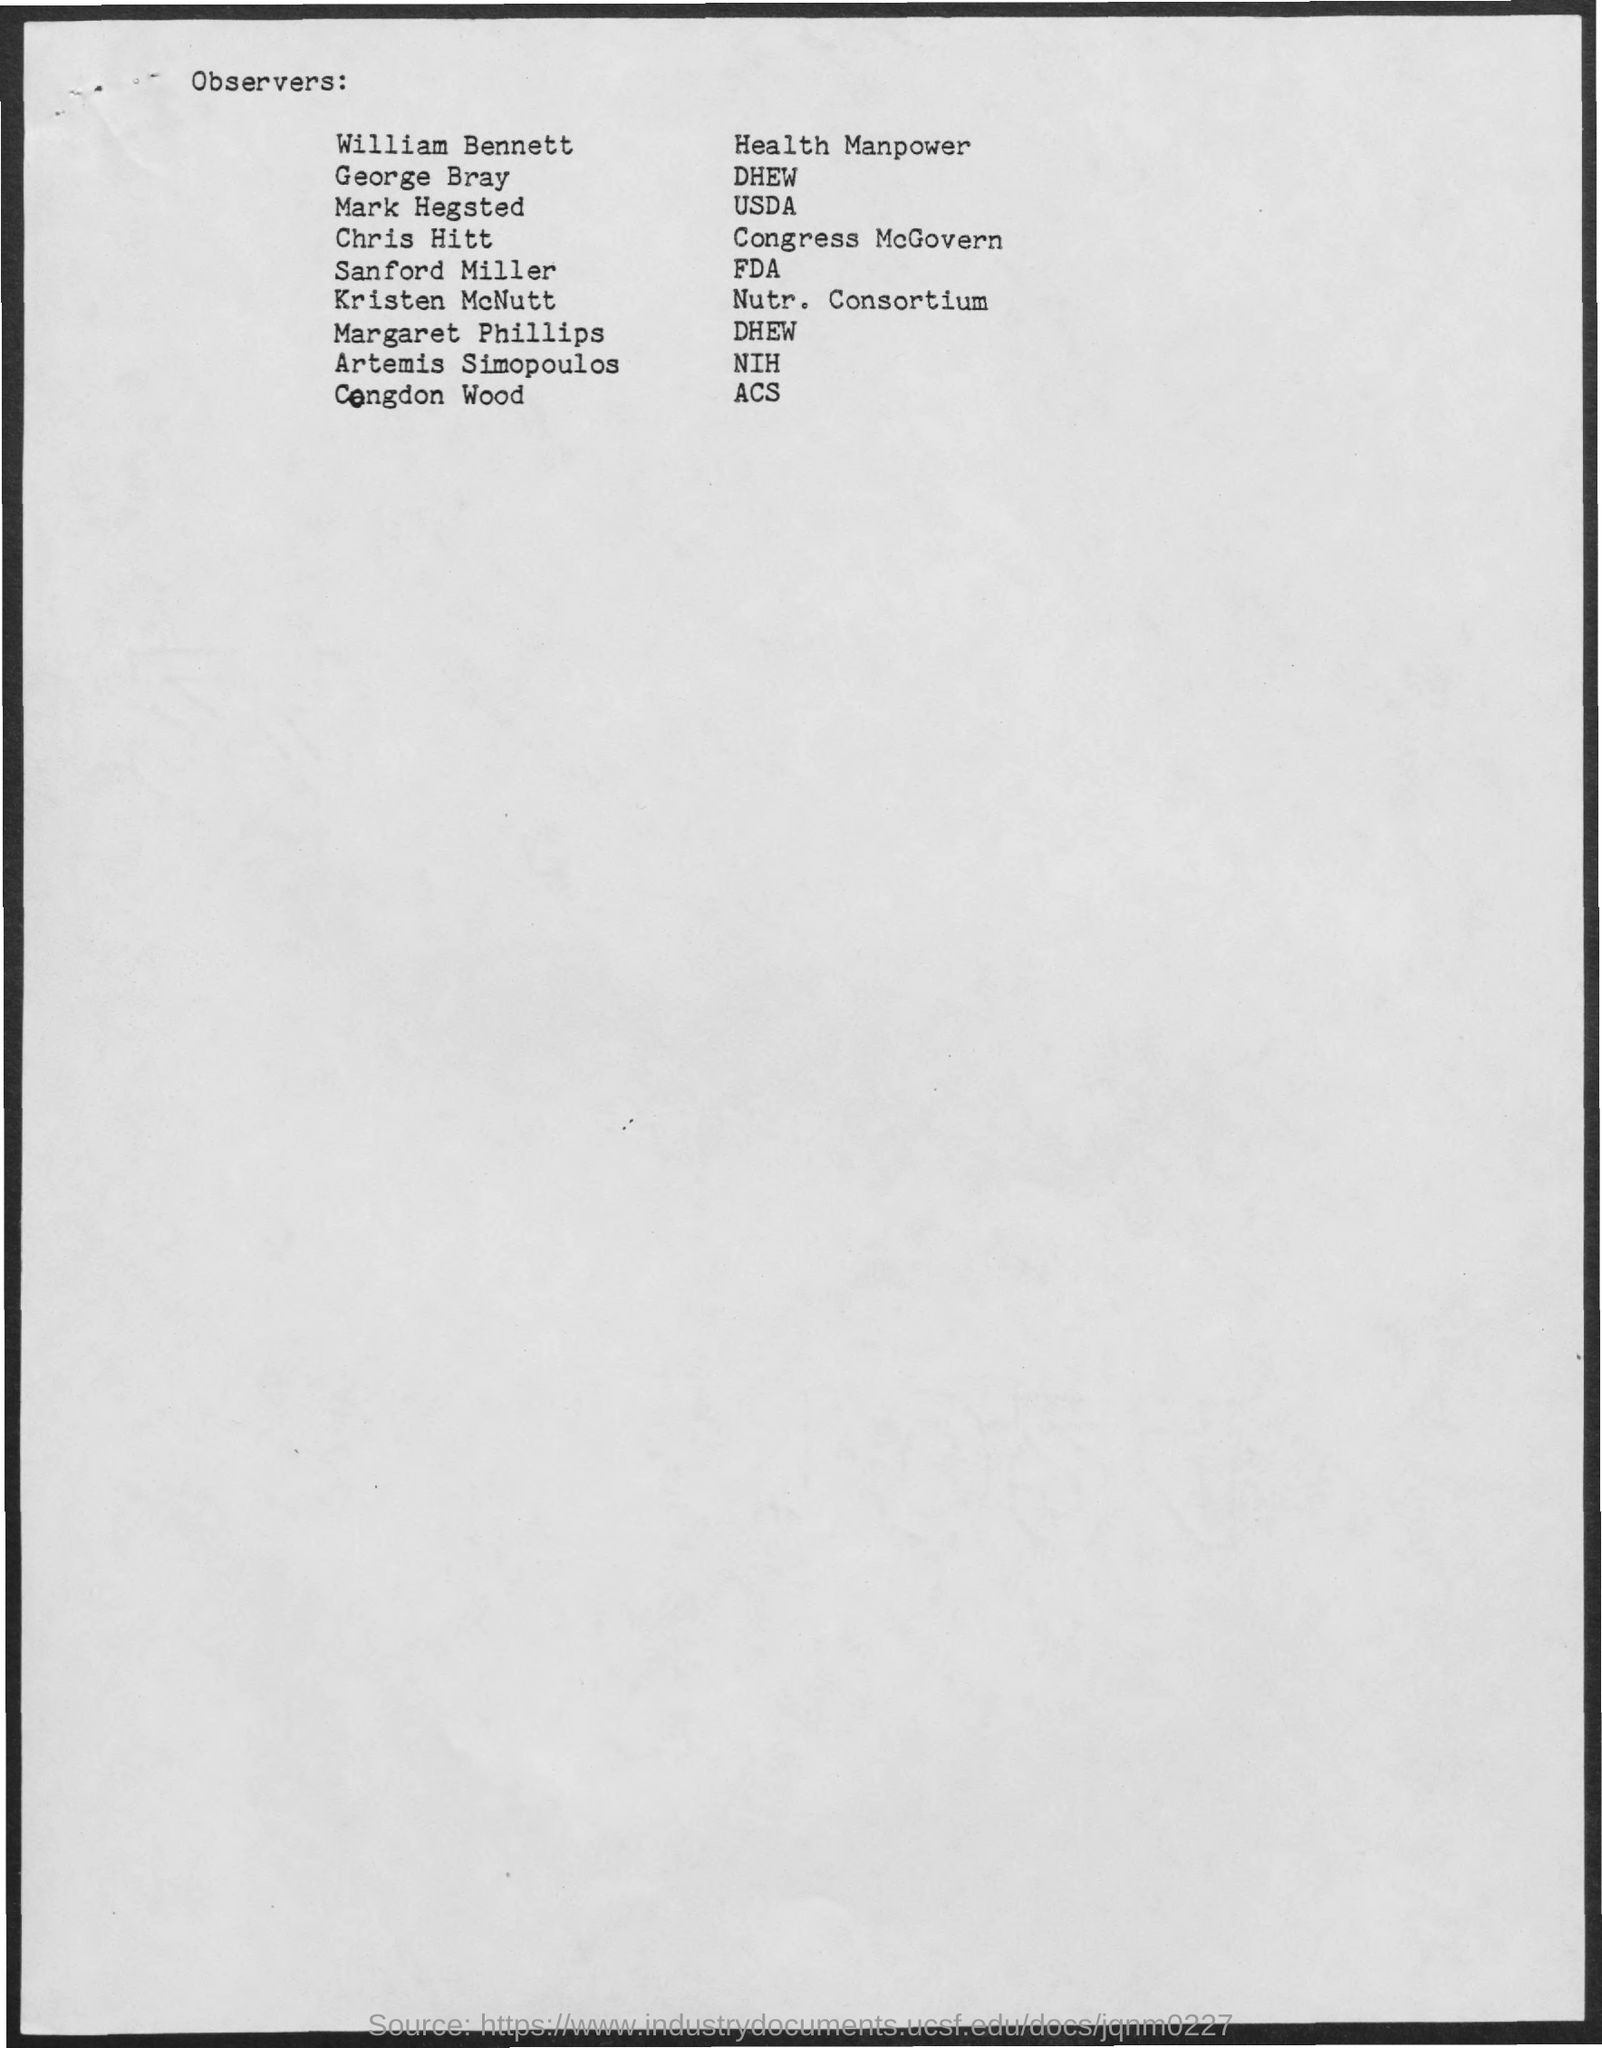DHEW is observed by whom?
Offer a terse response. George bray. 